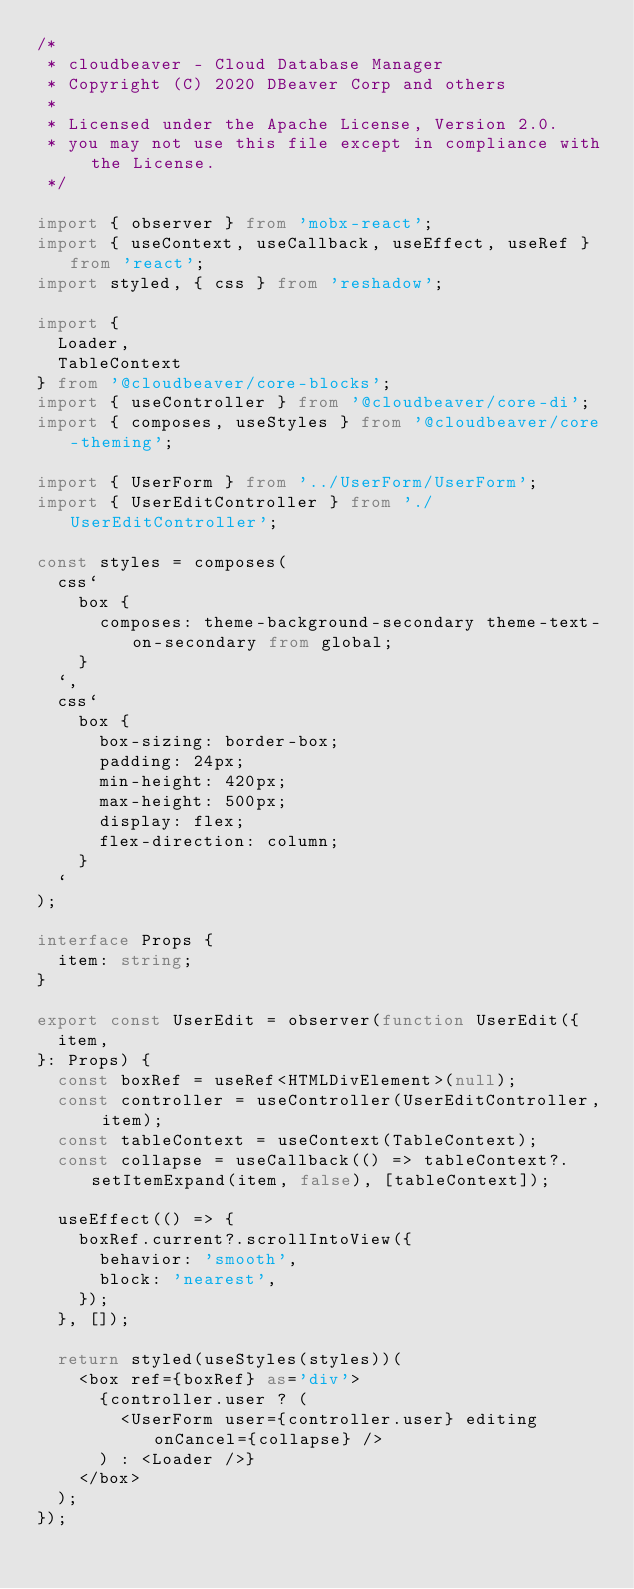Convert code to text. <code><loc_0><loc_0><loc_500><loc_500><_TypeScript_>/*
 * cloudbeaver - Cloud Database Manager
 * Copyright (C) 2020 DBeaver Corp and others
 *
 * Licensed under the Apache License, Version 2.0.
 * you may not use this file except in compliance with the License.
 */

import { observer } from 'mobx-react';
import { useContext, useCallback, useEffect, useRef } from 'react';
import styled, { css } from 'reshadow';

import {
  Loader,
  TableContext
} from '@cloudbeaver/core-blocks';
import { useController } from '@cloudbeaver/core-di';
import { composes, useStyles } from '@cloudbeaver/core-theming';

import { UserForm } from '../UserForm/UserForm';
import { UserEditController } from './UserEditController';

const styles = composes(
  css`
    box {
      composes: theme-background-secondary theme-text-on-secondary from global;
    }
  `,
  css`
    box {
      box-sizing: border-box;
      padding: 24px;
      min-height: 420px;
      max-height: 500px;
      display: flex;
      flex-direction: column;
    }
  `
);

interface Props {
  item: string;
}

export const UserEdit = observer(function UserEdit({
  item,
}: Props) {
  const boxRef = useRef<HTMLDivElement>(null);
  const controller = useController(UserEditController, item);
  const tableContext = useContext(TableContext);
  const collapse = useCallback(() => tableContext?.setItemExpand(item, false), [tableContext]);

  useEffect(() => {
    boxRef.current?.scrollIntoView({
      behavior: 'smooth',
      block: 'nearest',
    });
  }, []);

  return styled(useStyles(styles))(
    <box ref={boxRef} as='div'>
      {controller.user ? (
        <UserForm user={controller.user} editing onCancel={collapse} />
      ) : <Loader />}
    </box>
  );
});
</code> 